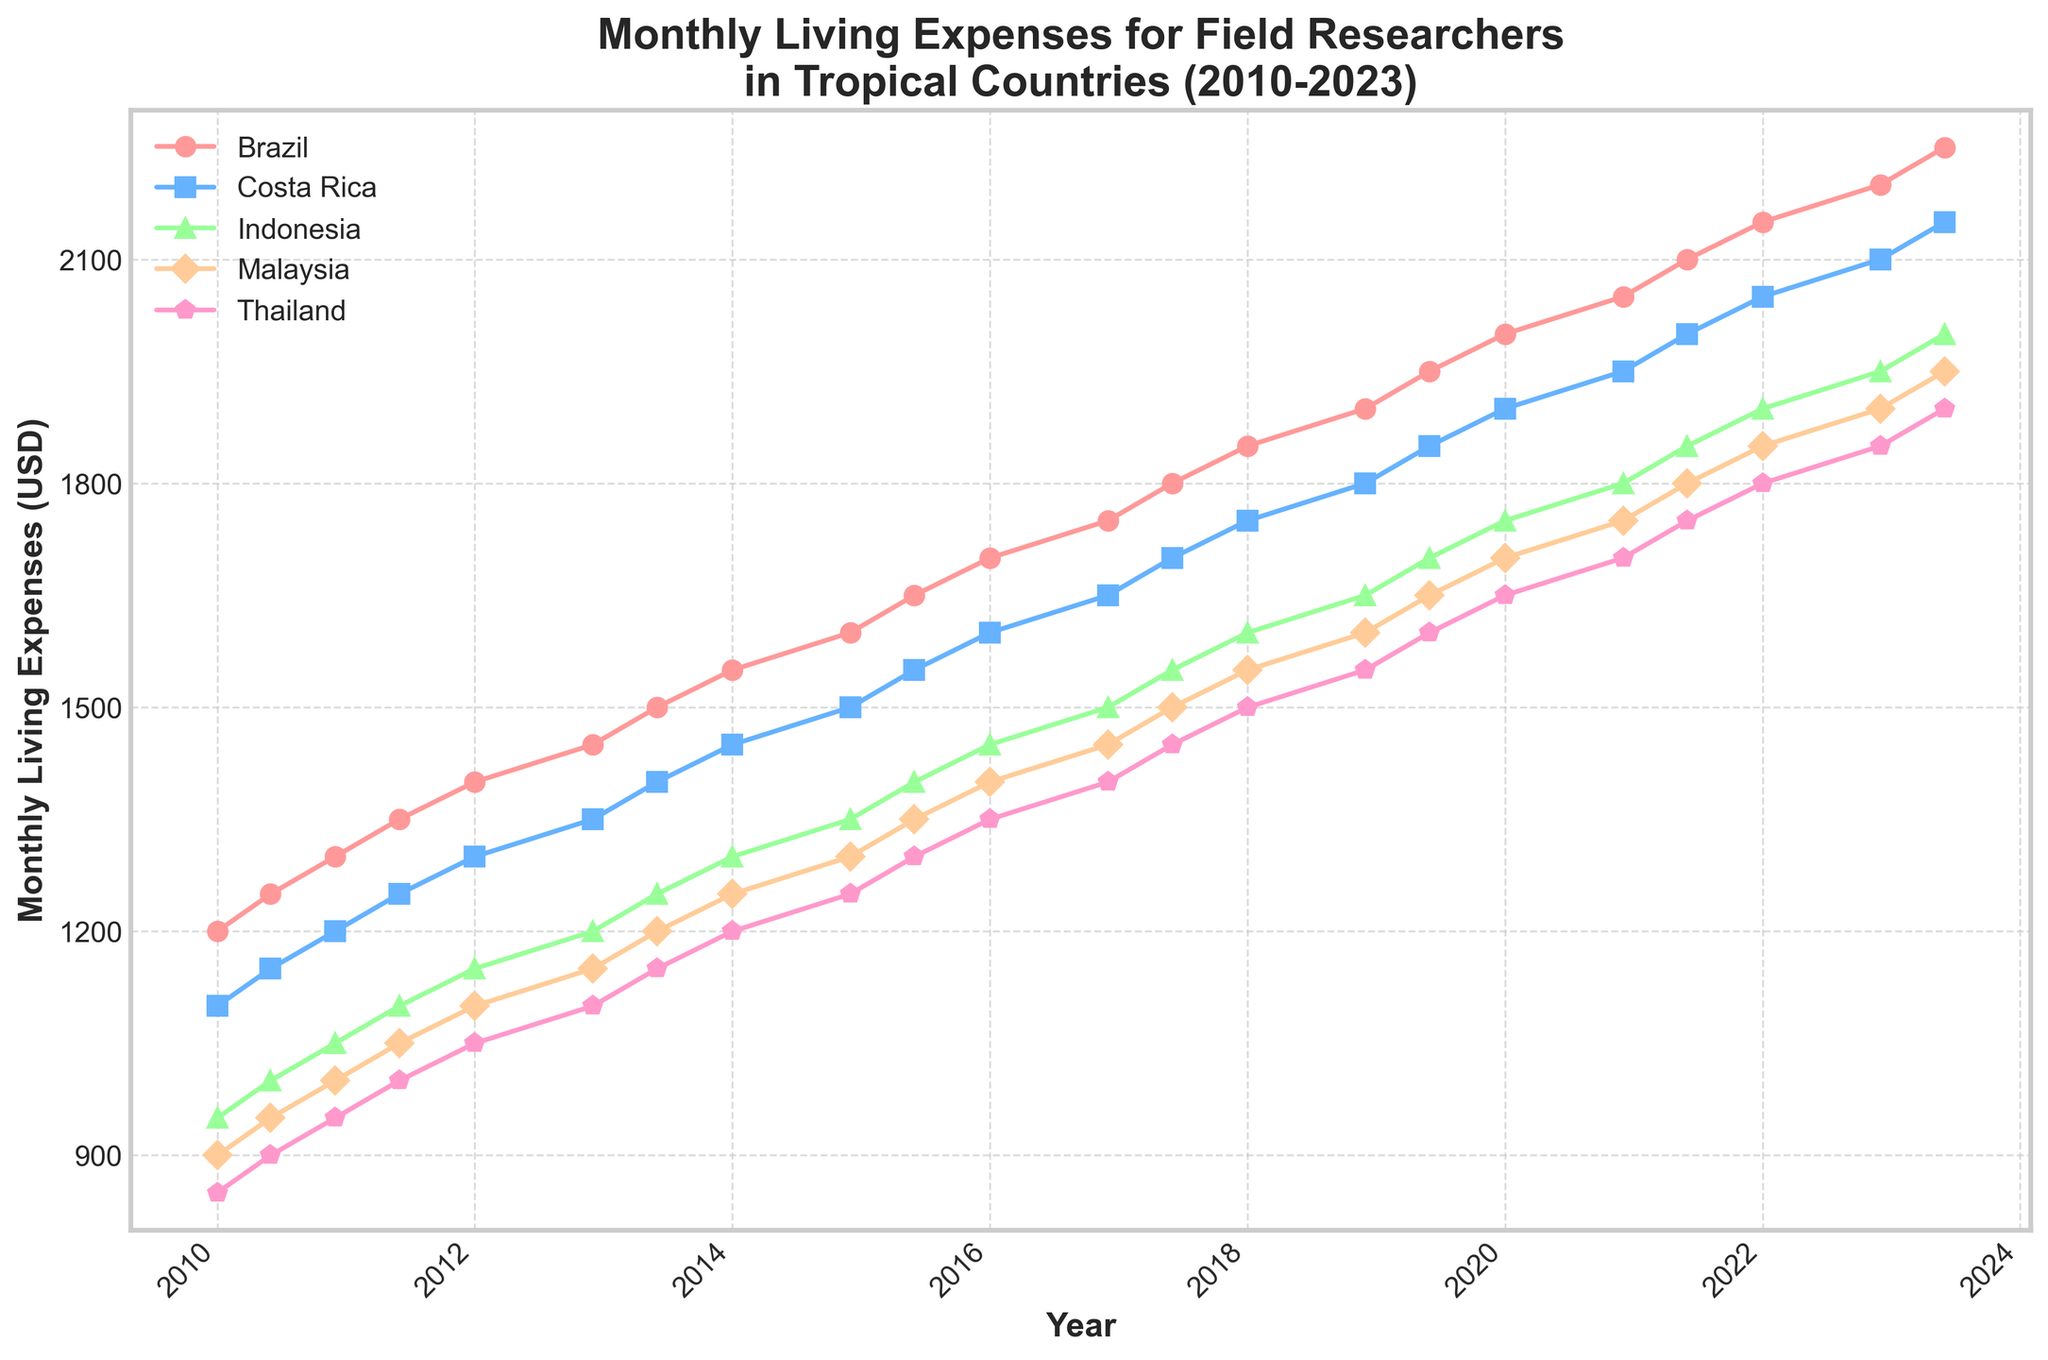What's the highest recorded monthly living expense in Brazil? The figure shows monthly living expenses over time, and the highest point on Brazil's line represents the highest expense. Looking at the plot, the highest value is at the end of 2023, which is $2250.
Answer: $2250 Between 2014 and 2018, which country had the steepest increase in living expenses? To find this, we need to check the slopes of the lines for each country from 2014 to 2018. Brazil increased from $1600 to $1850, Costa Rica from $1500 to $1750, Indonesia from $1350 to $1600, Malaysia from $1300 to $1550, and Thailand from $1250 to $1500. The differences are all $250, indicating that all countries had the same rate of increase in that period.
Answer: All countries Which country shows the smallest overall increase in living expenses from 2010 to 2023? Calculate the difference between the start and end points for each country's line. Brazil: $2250 - $1200 = $1050; Costa Rica: $2150 - $1100 = $1050; Indonesia: $2000 - $950 = $1050; Malaysia: $1950 - $900 = $1050; Thailand: $1900 - $850 = $1050. All countries have the same increase.
Answer: All countries In which year did Malaysia's living expenses first cross $1300? Look at the line for Malaysia and find the year when it first surpasses $1300. According to the plot, Malaysia's expenses first cross $1300 in 2014.
Answer: 2014 Compare the living expenses between Indonesia and Thailand in December 2022. Which country was cheaper to live in? Find the points for Indonesia and Thailand in December 2022. Indonesia's expense is $1950, and Thailand's is $1850. Therefore, Thailand was the cheaper option.
Answer: Thailand What's the average monthly living expense in Costa Rica for the years 2010 and 2011? Calculate the average of Costa Rica’s values for the given time frame. Summing the values in 2010 (1100, 1150, 1200) and 2011 (1250) gives us (1100 + 1150 + 1200 + 1250) = 4700, divided by 4 equals 1175.
Answer: 1175 During which year did Brazil's monthly living expenses increase the most? Look for the largest gap between points in Brazil's line for each year. From 2014 to 2015, the expense jumped from $1600 to $1650, the largest annual gain.
Answer: 2014-2015 What's the median value for Brazil's monthly living expenses from 2010 to 2023? For median, order Brazil’s expenses: [1200, 1250, 1300, 1350, 1400, 1450, 1500, 1550, 1600, 1650, 1700, 1750, 1800, 1850, 1900, 1950, 2000, 2050, 2100, 2150, 2200, 2250]. The median is the middle value, which is the average of the 11th and 12th values: (1700 + 1750) / 2 = 1725.
Answer: 1725 Which country's monthly living expenses remained below $2000 until the latest date on the plot? Look at each line and see which ones do not cross the $2000 threshold. Malaysia (max $1950) and Thailand (max $1900) remained under $2000.
Answer: Malaysia and Thailand 